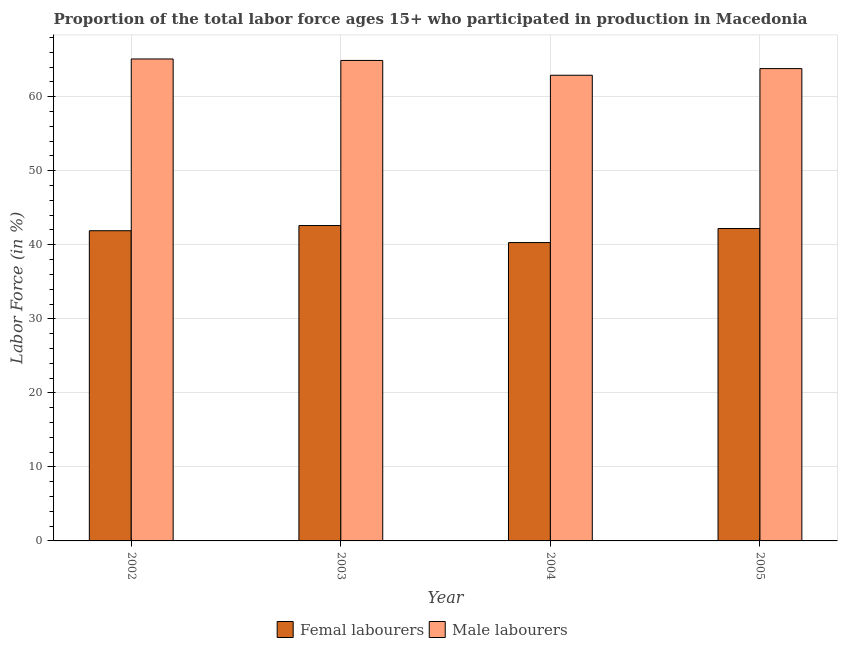How many different coloured bars are there?
Provide a short and direct response. 2. Are the number of bars on each tick of the X-axis equal?
Offer a terse response. Yes. How many bars are there on the 4th tick from the left?
Your response must be concise. 2. How many bars are there on the 3rd tick from the right?
Provide a short and direct response. 2. In how many cases, is the number of bars for a given year not equal to the number of legend labels?
Provide a short and direct response. 0. What is the percentage of male labour force in 2002?
Keep it short and to the point. 65.1. Across all years, what is the maximum percentage of female labor force?
Give a very brief answer. 42.6. Across all years, what is the minimum percentage of female labor force?
Your answer should be compact. 40.3. In which year was the percentage of female labor force maximum?
Your response must be concise. 2003. What is the total percentage of female labor force in the graph?
Provide a succinct answer. 167. What is the difference between the percentage of female labor force in 2003 and that in 2004?
Give a very brief answer. 2.3. What is the difference between the percentage of female labor force in 2003 and the percentage of male labour force in 2002?
Provide a short and direct response. 0.7. What is the average percentage of male labour force per year?
Your response must be concise. 64.18. In the year 2005, what is the difference between the percentage of male labour force and percentage of female labor force?
Offer a terse response. 0. In how many years, is the percentage of female labor force greater than 28 %?
Give a very brief answer. 4. What is the ratio of the percentage of male labour force in 2003 to that in 2004?
Keep it short and to the point. 1.03. Is the percentage of female labor force in 2003 less than that in 2005?
Offer a very short reply. No. Is the difference between the percentage of male labour force in 2002 and 2005 greater than the difference between the percentage of female labor force in 2002 and 2005?
Give a very brief answer. No. What is the difference between the highest and the second highest percentage of female labor force?
Make the answer very short. 0.4. What is the difference between the highest and the lowest percentage of male labour force?
Offer a terse response. 2.2. In how many years, is the percentage of male labour force greater than the average percentage of male labour force taken over all years?
Provide a succinct answer. 2. Is the sum of the percentage of female labor force in 2004 and 2005 greater than the maximum percentage of male labour force across all years?
Provide a succinct answer. Yes. What does the 2nd bar from the left in 2005 represents?
Offer a terse response. Male labourers. What does the 1st bar from the right in 2003 represents?
Your answer should be compact. Male labourers. Are all the bars in the graph horizontal?
Give a very brief answer. No. How many years are there in the graph?
Keep it short and to the point. 4. What is the difference between two consecutive major ticks on the Y-axis?
Give a very brief answer. 10. Are the values on the major ticks of Y-axis written in scientific E-notation?
Provide a short and direct response. No. Where does the legend appear in the graph?
Provide a succinct answer. Bottom center. How are the legend labels stacked?
Give a very brief answer. Horizontal. What is the title of the graph?
Offer a terse response. Proportion of the total labor force ages 15+ who participated in production in Macedonia. Does "Transport services" appear as one of the legend labels in the graph?
Ensure brevity in your answer.  No. What is the Labor Force (in %) in Femal labourers in 2002?
Your answer should be very brief. 41.9. What is the Labor Force (in %) in Male labourers in 2002?
Offer a very short reply. 65.1. What is the Labor Force (in %) in Femal labourers in 2003?
Offer a terse response. 42.6. What is the Labor Force (in %) in Male labourers in 2003?
Your answer should be very brief. 64.9. What is the Labor Force (in %) in Femal labourers in 2004?
Make the answer very short. 40.3. What is the Labor Force (in %) in Male labourers in 2004?
Offer a terse response. 62.9. What is the Labor Force (in %) of Femal labourers in 2005?
Provide a short and direct response. 42.2. What is the Labor Force (in %) of Male labourers in 2005?
Make the answer very short. 63.8. Across all years, what is the maximum Labor Force (in %) of Femal labourers?
Provide a succinct answer. 42.6. Across all years, what is the maximum Labor Force (in %) in Male labourers?
Provide a short and direct response. 65.1. Across all years, what is the minimum Labor Force (in %) in Femal labourers?
Offer a terse response. 40.3. Across all years, what is the minimum Labor Force (in %) in Male labourers?
Keep it short and to the point. 62.9. What is the total Labor Force (in %) of Femal labourers in the graph?
Provide a short and direct response. 167. What is the total Labor Force (in %) of Male labourers in the graph?
Your answer should be very brief. 256.7. What is the difference between the Labor Force (in %) of Femal labourers in 2002 and that in 2003?
Keep it short and to the point. -0.7. What is the difference between the Labor Force (in %) in Femal labourers in 2002 and that in 2004?
Offer a terse response. 1.6. What is the difference between the Labor Force (in %) of Femal labourers in 2002 and that in 2005?
Keep it short and to the point. -0.3. What is the difference between the Labor Force (in %) in Male labourers in 2002 and that in 2005?
Offer a very short reply. 1.3. What is the difference between the Labor Force (in %) in Male labourers in 2003 and that in 2004?
Offer a very short reply. 2. What is the difference between the Labor Force (in %) in Femal labourers in 2003 and that in 2005?
Provide a succinct answer. 0.4. What is the difference between the Labor Force (in %) in Femal labourers in 2004 and that in 2005?
Offer a terse response. -1.9. What is the difference between the Labor Force (in %) in Femal labourers in 2002 and the Labor Force (in %) in Male labourers in 2003?
Keep it short and to the point. -23. What is the difference between the Labor Force (in %) in Femal labourers in 2002 and the Labor Force (in %) in Male labourers in 2005?
Keep it short and to the point. -21.9. What is the difference between the Labor Force (in %) in Femal labourers in 2003 and the Labor Force (in %) in Male labourers in 2004?
Ensure brevity in your answer.  -20.3. What is the difference between the Labor Force (in %) of Femal labourers in 2003 and the Labor Force (in %) of Male labourers in 2005?
Make the answer very short. -21.2. What is the difference between the Labor Force (in %) of Femal labourers in 2004 and the Labor Force (in %) of Male labourers in 2005?
Give a very brief answer. -23.5. What is the average Labor Force (in %) of Femal labourers per year?
Your answer should be compact. 41.75. What is the average Labor Force (in %) of Male labourers per year?
Provide a succinct answer. 64.17. In the year 2002, what is the difference between the Labor Force (in %) in Femal labourers and Labor Force (in %) in Male labourers?
Offer a terse response. -23.2. In the year 2003, what is the difference between the Labor Force (in %) in Femal labourers and Labor Force (in %) in Male labourers?
Provide a succinct answer. -22.3. In the year 2004, what is the difference between the Labor Force (in %) of Femal labourers and Labor Force (in %) of Male labourers?
Your response must be concise. -22.6. In the year 2005, what is the difference between the Labor Force (in %) in Femal labourers and Labor Force (in %) in Male labourers?
Your response must be concise. -21.6. What is the ratio of the Labor Force (in %) in Femal labourers in 2002 to that in 2003?
Offer a terse response. 0.98. What is the ratio of the Labor Force (in %) of Male labourers in 2002 to that in 2003?
Make the answer very short. 1. What is the ratio of the Labor Force (in %) in Femal labourers in 2002 to that in 2004?
Your response must be concise. 1.04. What is the ratio of the Labor Force (in %) of Male labourers in 2002 to that in 2004?
Offer a terse response. 1.03. What is the ratio of the Labor Force (in %) of Male labourers in 2002 to that in 2005?
Offer a terse response. 1.02. What is the ratio of the Labor Force (in %) in Femal labourers in 2003 to that in 2004?
Your answer should be very brief. 1.06. What is the ratio of the Labor Force (in %) of Male labourers in 2003 to that in 2004?
Your answer should be compact. 1.03. What is the ratio of the Labor Force (in %) in Femal labourers in 2003 to that in 2005?
Give a very brief answer. 1.01. What is the ratio of the Labor Force (in %) of Male labourers in 2003 to that in 2005?
Make the answer very short. 1.02. What is the ratio of the Labor Force (in %) in Femal labourers in 2004 to that in 2005?
Make the answer very short. 0.95. What is the ratio of the Labor Force (in %) in Male labourers in 2004 to that in 2005?
Your answer should be compact. 0.99. What is the difference between the highest and the second highest Labor Force (in %) in Male labourers?
Provide a short and direct response. 0.2. 